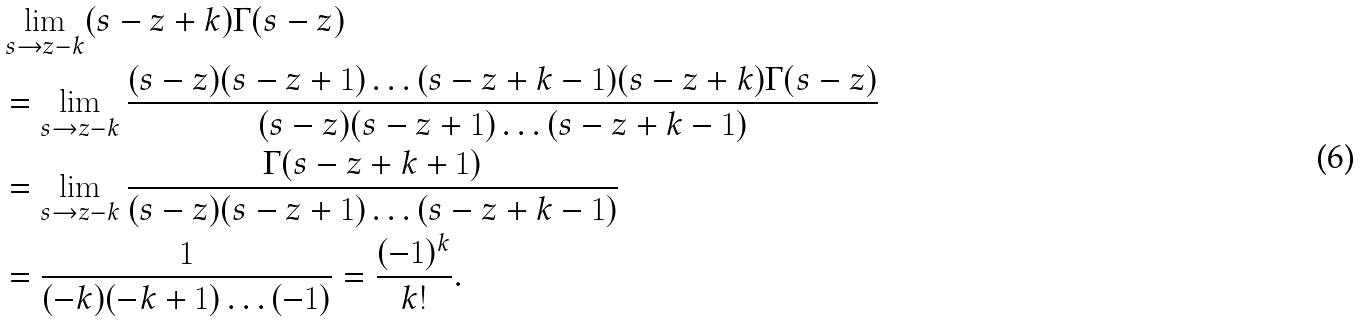Convert formula to latex. <formula><loc_0><loc_0><loc_500><loc_500>& \lim _ { s \rightarrow z - k } ( s - z + k ) \Gamma ( s - z ) \\ & = \lim _ { s \rightarrow z - k } \frac { ( s - z ) ( s - z + 1 ) \dots ( s - z + k - 1 ) ( s - z + k ) \Gamma ( s - z ) } { ( s - z ) ( s - z + 1 ) \dots ( s - z + k - 1 ) } \\ & = \lim _ { s \rightarrow z - k } \frac { \Gamma ( s - z + k + 1 ) } { ( s - z ) ( s - z + 1 ) \dots ( s - z + k - 1 ) } \\ & = \frac { 1 } { ( - k ) ( - k + 1 ) \dots ( - 1 ) } = \frac { ( - 1 ) ^ { k } } { k ! } .</formula> 